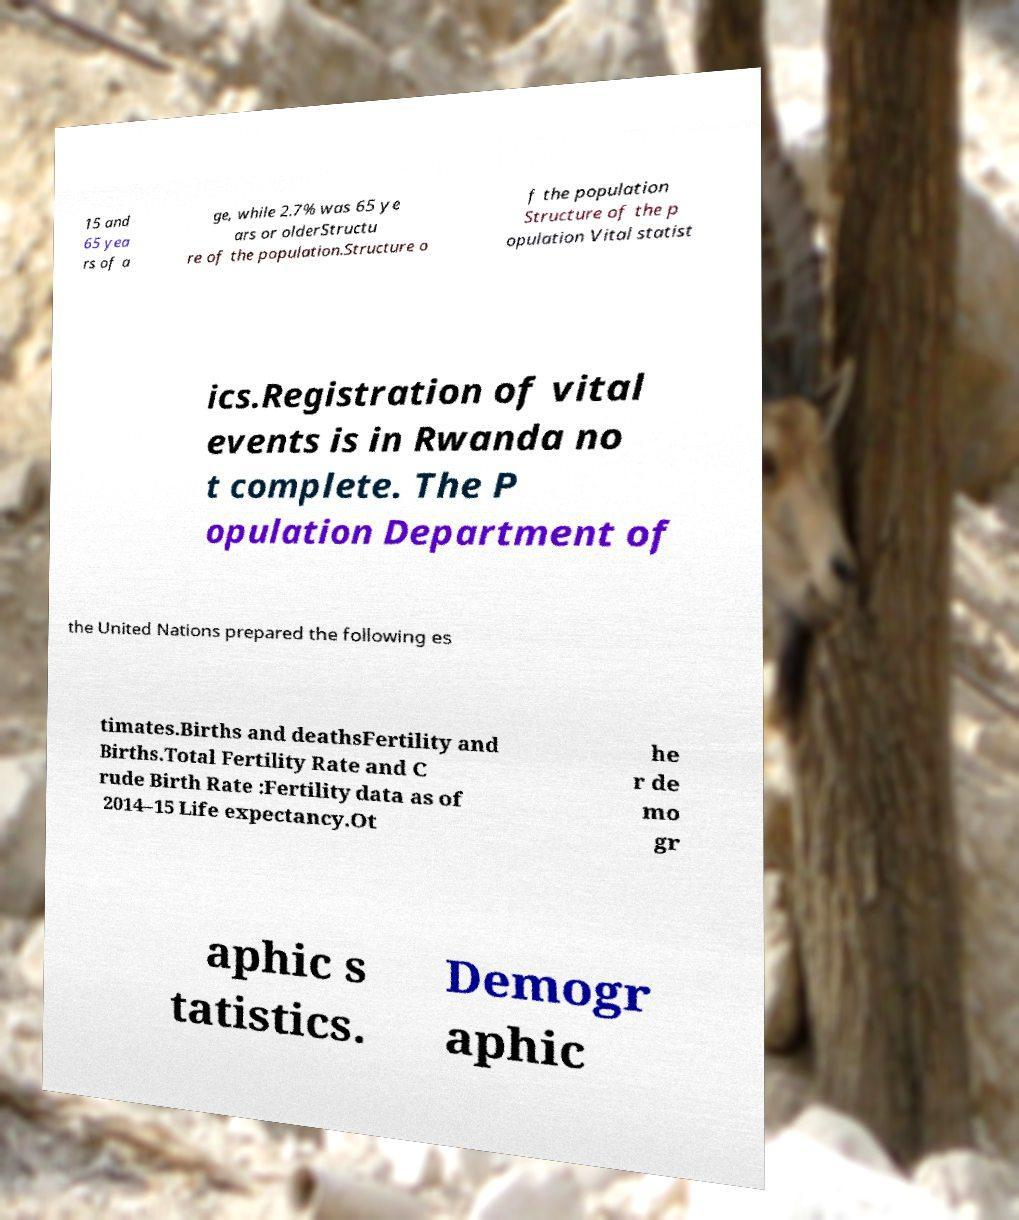Please read and relay the text visible in this image. What does it say? 15 and 65 yea rs of a ge, while 2.7% was 65 ye ars or olderStructu re of the population.Structure o f the population Structure of the p opulation Vital statist ics.Registration of vital events is in Rwanda no t complete. The P opulation Department of the United Nations prepared the following es timates.Births and deathsFertility and Births.Total Fertility Rate and C rude Birth Rate :Fertility data as of 2014–15 Life expectancy.Ot he r de mo gr aphic s tatistics. Demogr aphic 